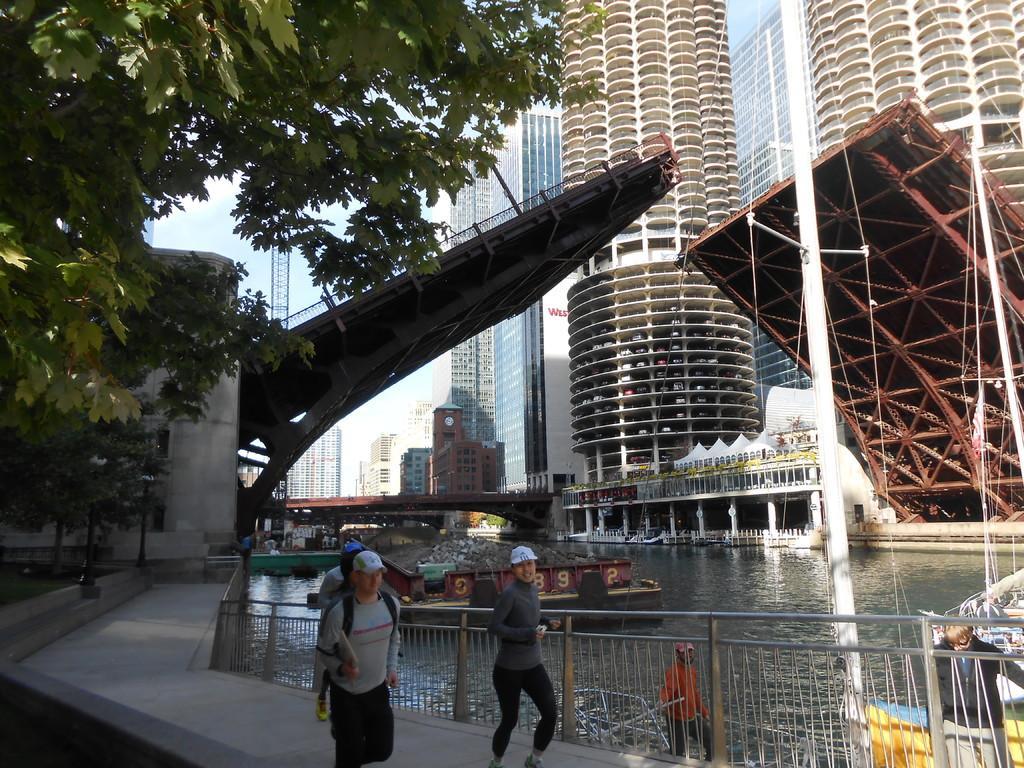Can you describe this image briefly? In this picture I can see three persons were running on the street, beside them I can see the fencing. At the bottom there is a man who is wearing red t-shirt and jeans. He is standing on the boat. In the center I can see the bridge which is opened. In the background I can see other bridge, buildings, boards, persons and other objects. On the left I can see the trees. At the top I can see the sky and clouds. 